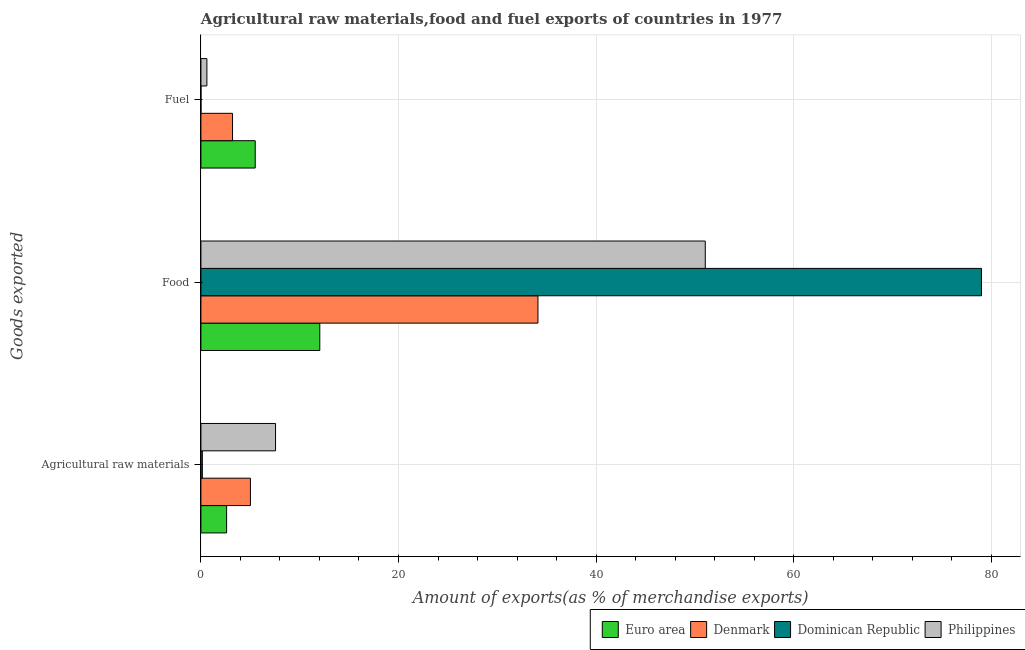Are the number of bars per tick equal to the number of legend labels?
Offer a very short reply. Yes. How many bars are there on the 3rd tick from the bottom?
Your response must be concise. 4. What is the label of the 3rd group of bars from the top?
Provide a short and direct response. Agricultural raw materials. What is the percentage of raw materials exports in Denmark?
Keep it short and to the point. 5.01. Across all countries, what is the maximum percentage of fuel exports?
Provide a succinct answer. 5.5. Across all countries, what is the minimum percentage of food exports?
Your response must be concise. 12.03. In which country was the percentage of food exports maximum?
Offer a terse response. Dominican Republic. In which country was the percentage of raw materials exports minimum?
Provide a succinct answer. Dominican Republic. What is the total percentage of food exports in the graph?
Your answer should be very brief. 176.22. What is the difference between the percentage of food exports in Dominican Republic and that in Philippines?
Your answer should be very brief. 27.96. What is the difference between the percentage of fuel exports in Denmark and the percentage of food exports in Euro area?
Provide a short and direct response. -8.83. What is the average percentage of food exports per country?
Provide a succinct answer. 44.05. What is the difference between the percentage of fuel exports and percentage of food exports in Dominican Republic?
Your response must be concise. -79.01. In how many countries, is the percentage of raw materials exports greater than 12 %?
Keep it short and to the point. 0. What is the ratio of the percentage of raw materials exports in Euro area to that in Philippines?
Provide a succinct answer. 0.34. Is the percentage of raw materials exports in Philippines less than that in Denmark?
Provide a succinct answer. No. What is the difference between the highest and the second highest percentage of raw materials exports?
Keep it short and to the point. 2.54. What is the difference between the highest and the lowest percentage of raw materials exports?
Keep it short and to the point. 7.41. Is the sum of the percentage of raw materials exports in Euro area and Dominican Republic greater than the maximum percentage of fuel exports across all countries?
Provide a succinct answer. No. What does the 3rd bar from the top in Fuel represents?
Offer a very short reply. Denmark. What does the 2nd bar from the bottom in Food represents?
Your response must be concise. Denmark. What is the difference between two consecutive major ticks on the X-axis?
Give a very brief answer. 20. Where does the legend appear in the graph?
Ensure brevity in your answer.  Bottom right. How many legend labels are there?
Ensure brevity in your answer.  4. What is the title of the graph?
Your answer should be very brief. Agricultural raw materials,food and fuel exports of countries in 1977. Does "Bermuda" appear as one of the legend labels in the graph?
Your answer should be compact. No. What is the label or title of the X-axis?
Offer a very short reply. Amount of exports(as % of merchandise exports). What is the label or title of the Y-axis?
Keep it short and to the point. Goods exported. What is the Amount of exports(as % of merchandise exports) of Euro area in Agricultural raw materials?
Give a very brief answer. 2.6. What is the Amount of exports(as % of merchandise exports) in Denmark in Agricultural raw materials?
Keep it short and to the point. 5.01. What is the Amount of exports(as % of merchandise exports) in Dominican Republic in Agricultural raw materials?
Give a very brief answer. 0.14. What is the Amount of exports(as % of merchandise exports) in Philippines in Agricultural raw materials?
Your answer should be very brief. 7.55. What is the Amount of exports(as % of merchandise exports) of Euro area in Food?
Provide a short and direct response. 12.03. What is the Amount of exports(as % of merchandise exports) of Denmark in Food?
Your answer should be compact. 34.12. What is the Amount of exports(as % of merchandise exports) of Dominican Republic in Food?
Ensure brevity in your answer.  79.01. What is the Amount of exports(as % of merchandise exports) of Philippines in Food?
Offer a very short reply. 51.05. What is the Amount of exports(as % of merchandise exports) in Euro area in Fuel?
Provide a succinct answer. 5.5. What is the Amount of exports(as % of merchandise exports) of Denmark in Fuel?
Your answer should be very brief. 3.2. What is the Amount of exports(as % of merchandise exports) of Dominican Republic in Fuel?
Make the answer very short. 0. What is the Amount of exports(as % of merchandise exports) in Philippines in Fuel?
Your answer should be compact. 0.61. Across all Goods exported, what is the maximum Amount of exports(as % of merchandise exports) in Euro area?
Provide a succinct answer. 12.03. Across all Goods exported, what is the maximum Amount of exports(as % of merchandise exports) in Denmark?
Give a very brief answer. 34.12. Across all Goods exported, what is the maximum Amount of exports(as % of merchandise exports) in Dominican Republic?
Provide a short and direct response. 79.01. Across all Goods exported, what is the maximum Amount of exports(as % of merchandise exports) of Philippines?
Offer a very short reply. 51.05. Across all Goods exported, what is the minimum Amount of exports(as % of merchandise exports) in Euro area?
Your answer should be very brief. 2.6. Across all Goods exported, what is the minimum Amount of exports(as % of merchandise exports) of Denmark?
Make the answer very short. 3.2. Across all Goods exported, what is the minimum Amount of exports(as % of merchandise exports) in Dominican Republic?
Ensure brevity in your answer.  0. Across all Goods exported, what is the minimum Amount of exports(as % of merchandise exports) in Philippines?
Make the answer very short. 0.61. What is the total Amount of exports(as % of merchandise exports) of Euro area in the graph?
Your answer should be compact. 20.13. What is the total Amount of exports(as % of merchandise exports) in Denmark in the graph?
Give a very brief answer. 42.33. What is the total Amount of exports(as % of merchandise exports) in Dominican Republic in the graph?
Give a very brief answer. 79.16. What is the total Amount of exports(as % of merchandise exports) of Philippines in the graph?
Provide a succinct answer. 59.21. What is the difference between the Amount of exports(as % of merchandise exports) of Euro area in Agricultural raw materials and that in Food?
Provide a succinct answer. -9.43. What is the difference between the Amount of exports(as % of merchandise exports) of Denmark in Agricultural raw materials and that in Food?
Provide a succinct answer. -29.11. What is the difference between the Amount of exports(as % of merchandise exports) of Dominican Republic in Agricultural raw materials and that in Food?
Keep it short and to the point. -78.87. What is the difference between the Amount of exports(as % of merchandise exports) of Philippines in Agricultural raw materials and that in Food?
Provide a succinct answer. -43.5. What is the difference between the Amount of exports(as % of merchandise exports) of Euro area in Agricultural raw materials and that in Fuel?
Make the answer very short. -2.9. What is the difference between the Amount of exports(as % of merchandise exports) in Denmark in Agricultural raw materials and that in Fuel?
Your response must be concise. 1.81. What is the difference between the Amount of exports(as % of merchandise exports) of Dominican Republic in Agricultural raw materials and that in Fuel?
Keep it short and to the point. 0.14. What is the difference between the Amount of exports(as % of merchandise exports) of Philippines in Agricultural raw materials and that in Fuel?
Offer a very short reply. 6.95. What is the difference between the Amount of exports(as % of merchandise exports) of Euro area in Food and that in Fuel?
Provide a short and direct response. 6.54. What is the difference between the Amount of exports(as % of merchandise exports) of Denmark in Food and that in Fuel?
Provide a short and direct response. 30.92. What is the difference between the Amount of exports(as % of merchandise exports) of Dominican Republic in Food and that in Fuel?
Give a very brief answer. 79.01. What is the difference between the Amount of exports(as % of merchandise exports) of Philippines in Food and that in Fuel?
Provide a succinct answer. 50.45. What is the difference between the Amount of exports(as % of merchandise exports) in Euro area in Agricultural raw materials and the Amount of exports(as % of merchandise exports) in Denmark in Food?
Your answer should be very brief. -31.52. What is the difference between the Amount of exports(as % of merchandise exports) of Euro area in Agricultural raw materials and the Amount of exports(as % of merchandise exports) of Dominican Republic in Food?
Your answer should be very brief. -76.41. What is the difference between the Amount of exports(as % of merchandise exports) in Euro area in Agricultural raw materials and the Amount of exports(as % of merchandise exports) in Philippines in Food?
Your answer should be compact. -48.45. What is the difference between the Amount of exports(as % of merchandise exports) of Denmark in Agricultural raw materials and the Amount of exports(as % of merchandise exports) of Dominican Republic in Food?
Make the answer very short. -74. What is the difference between the Amount of exports(as % of merchandise exports) of Denmark in Agricultural raw materials and the Amount of exports(as % of merchandise exports) of Philippines in Food?
Your answer should be compact. -46.04. What is the difference between the Amount of exports(as % of merchandise exports) of Dominican Republic in Agricultural raw materials and the Amount of exports(as % of merchandise exports) of Philippines in Food?
Provide a succinct answer. -50.91. What is the difference between the Amount of exports(as % of merchandise exports) of Euro area in Agricultural raw materials and the Amount of exports(as % of merchandise exports) of Denmark in Fuel?
Offer a terse response. -0.6. What is the difference between the Amount of exports(as % of merchandise exports) of Euro area in Agricultural raw materials and the Amount of exports(as % of merchandise exports) of Dominican Republic in Fuel?
Offer a very short reply. 2.6. What is the difference between the Amount of exports(as % of merchandise exports) in Euro area in Agricultural raw materials and the Amount of exports(as % of merchandise exports) in Philippines in Fuel?
Your response must be concise. 1.99. What is the difference between the Amount of exports(as % of merchandise exports) in Denmark in Agricultural raw materials and the Amount of exports(as % of merchandise exports) in Dominican Republic in Fuel?
Offer a very short reply. 5.01. What is the difference between the Amount of exports(as % of merchandise exports) in Denmark in Agricultural raw materials and the Amount of exports(as % of merchandise exports) in Philippines in Fuel?
Your answer should be compact. 4.41. What is the difference between the Amount of exports(as % of merchandise exports) in Dominican Republic in Agricultural raw materials and the Amount of exports(as % of merchandise exports) in Philippines in Fuel?
Ensure brevity in your answer.  -0.46. What is the difference between the Amount of exports(as % of merchandise exports) of Euro area in Food and the Amount of exports(as % of merchandise exports) of Denmark in Fuel?
Your response must be concise. 8.83. What is the difference between the Amount of exports(as % of merchandise exports) of Euro area in Food and the Amount of exports(as % of merchandise exports) of Dominican Republic in Fuel?
Make the answer very short. 12.03. What is the difference between the Amount of exports(as % of merchandise exports) in Euro area in Food and the Amount of exports(as % of merchandise exports) in Philippines in Fuel?
Your response must be concise. 11.43. What is the difference between the Amount of exports(as % of merchandise exports) of Denmark in Food and the Amount of exports(as % of merchandise exports) of Dominican Republic in Fuel?
Your response must be concise. 34.11. What is the difference between the Amount of exports(as % of merchandise exports) of Denmark in Food and the Amount of exports(as % of merchandise exports) of Philippines in Fuel?
Your response must be concise. 33.51. What is the difference between the Amount of exports(as % of merchandise exports) of Dominican Republic in Food and the Amount of exports(as % of merchandise exports) of Philippines in Fuel?
Make the answer very short. 78.41. What is the average Amount of exports(as % of merchandise exports) in Euro area per Goods exported?
Ensure brevity in your answer.  6.71. What is the average Amount of exports(as % of merchandise exports) in Denmark per Goods exported?
Make the answer very short. 14.11. What is the average Amount of exports(as % of merchandise exports) in Dominican Republic per Goods exported?
Keep it short and to the point. 26.39. What is the average Amount of exports(as % of merchandise exports) of Philippines per Goods exported?
Your answer should be compact. 19.74. What is the difference between the Amount of exports(as % of merchandise exports) of Euro area and Amount of exports(as % of merchandise exports) of Denmark in Agricultural raw materials?
Your response must be concise. -2.41. What is the difference between the Amount of exports(as % of merchandise exports) of Euro area and Amount of exports(as % of merchandise exports) of Dominican Republic in Agricultural raw materials?
Offer a very short reply. 2.46. What is the difference between the Amount of exports(as % of merchandise exports) in Euro area and Amount of exports(as % of merchandise exports) in Philippines in Agricultural raw materials?
Your answer should be compact. -4.95. What is the difference between the Amount of exports(as % of merchandise exports) in Denmark and Amount of exports(as % of merchandise exports) in Dominican Republic in Agricultural raw materials?
Make the answer very short. 4.87. What is the difference between the Amount of exports(as % of merchandise exports) in Denmark and Amount of exports(as % of merchandise exports) in Philippines in Agricultural raw materials?
Offer a very short reply. -2.54. What is the difference between the Amount of exports(as % of merchandise exports) in Dominican Republic and Amount of exports(as % of merchandise exports) in Philippines in Agricultural raw materials?
Give a very brief answer. -7.41. What is the difference between the Amount of exports(as % of merchandise exports) of Euro area and Amount of exports(as % of merchandise exports) of Denmark in Food?
Ensure brevity in your answer.  -22.08. What is the difference between the Amount of exports(as % of merchandise exports) in Euro area and Amount of exports(as % of merchandise exports) in Dominican Republic in Food?
Provide a short and direct response. -66.98. What is the difference between the Amount of exports(as % of merchandise exports) in Euro area and Amount of exports(as % of merchandise exports) in Philippines in Food?
Offer a terse response. -39.02. What is the difference between the Amount of exports(as % of merchandise exports) in Denmark and Amount of exports(as % of merchandise exports) in Dominican Republic in Food?
Your answer should be very brief. -44.9. What is the difference between the Amount of exports(as % of merchandise exports) in Denmark and Amount of exports(as % of merchandise exports) in Philippines in Food?
Give a very brief answer. -16.94. What is the difference between the Amount of exports(as % of merchandise exports) of Dominican Republic and Amount of exports(as % of merchandise exports) of Philippines in Food?
Your response must be concise. 27.96. What is the difference between the Amount of exports(as % of merchandise exports) in Euro area and Amount of exports(as % of merchandise exports) in Denmark in Fuel?
Your answer should be very brief. 2.3. What is the difference between the Amount of exports(as % of merchandise exports) in Euro area and Amount of exports(as % of merchandise exports) in Dominican Republic in Fuel?
Keep it short and to the point. 5.49. What is the difference between the Amount of exports(as % of merchandise exports) of Euro area and Amount of exports(as % of merchandise exports) of Philippines in Fuel?
Keep it short and to the point. 4.89. What is the difference between the Amount of exports(as % of merchandise exports) in Denmark and Amount of exports(as % of merchandise exports) in Dominican Republic in Fuel?
Make the answer very short. 3.2. What is the difference between the Amount of exports(as % of merchandise exports) of Denmark and Amount of exports(as % of merchandise exports) of Philippines in Fuel?
Keep it short and to the point. 2.6. What is the difference between the Amount of exports(as % of merchandise exports) of Dominican Republic and Amount of exports(as % of merchandise exports) of Philippines in Fuel?
Your response must be concise. -0.6. What is the ratio of the Amount of exports(as % of merchandise exports) of Euro area in Agricultural raw materials to that in Food?
Offer a very short reply. 0.22. What is the ratio of the Amount of exports(as % of merchandise exports) in Denmark in Agricultural raw materials to that in Food?
Offer a terse response. 0.15. What is the ratio of the Amount of exports(as % of merchandise exports) of Dominican Republic in Agricultural raw materials to that in Food?
Your response must be concise. 0. What is the ratio of the Amount of exports(as % of merchandise exports) of Philippines in Agricultural raw materials to that in Food?
Give a very brief answer. 0.15. What is the ratio of the Amount of exports(as % of merchandise exports) in Euro area in Agricultural raw materials to that in Fuel?
Provide a succinct answer. 0.47. What is the ratio of the Amount of exports(as % of merchandise exports) in Denmark in Agricultural raw materials to that in Fuel?
Offer a terse response. 1.57. What is the ratio of the Amount of exports(as % of merchandise exports) in Dominican Republic in Agricultural raw materials to that in Fuel?
Provide a succinct answer. 73.14. What is the ratio of the Amount of exports(as % of merchandise exports) in Philippines in Agricultural raw materials to that in Fuel?
Your answer should be compact. 12.48. What is the ratio of the Amount of exports(as % of merchandise exports) of Euro area in Food to that in Fuel?
Keep it short and to the point. 2.19. What is the ratio of the Amount of exports(as % of merchandise exports) of Denmark in Food to that in Fuel?
Ensure brevity in your answer.  10.66. What is the ratio of the Amount of exports(as % of merchandise exports) in Dominican Republic in Food to that in Fuel?
Offer a very short reply. 4.00e+04. What is the ratio of the Amount of exports(as % of merchandise exports) of Philippines in Food to that in Fuel?
Your answer should be compact. 84.35. What is the difference between the highest and the second highest Amount of exports(as % of merchandise exports) in Euro area?
Provide a short and direct response. 6.54. What is the difference between the highest and the second highest Amount of exports(as % of merchandise exports) of Denmark?
Offer a very short reply. 29.11. What is the difference between the highest and the second highest Amount of exports(as % of merchandise exports) in Dominican Republic?
Offer a very short reply. 78.87. What is the difference between the highest and the second highest Amount of exports(as % of merchandise exports) of Philippines?
Your response must be concise. 43.5. What is the difference between the highest and the lowest Amount of exports(as % of merchandise exports) of Euro area?
Your answer should be compact. 9.43. What is the difference between the highest and the lowest Amount of exports(as % of merchandise exports) of Denmark?
Offer a terse response. 30.92. What is the difference between the highest and the lowest Amount of exports(as % of merchandise exports) in Dominican Republic?
Offer a very short reply. 79.01. What is the difference between the highest and the lowest Amount of exports(as % of merchandise exports) in Philippines?
Make the answer very short. 50.45. 